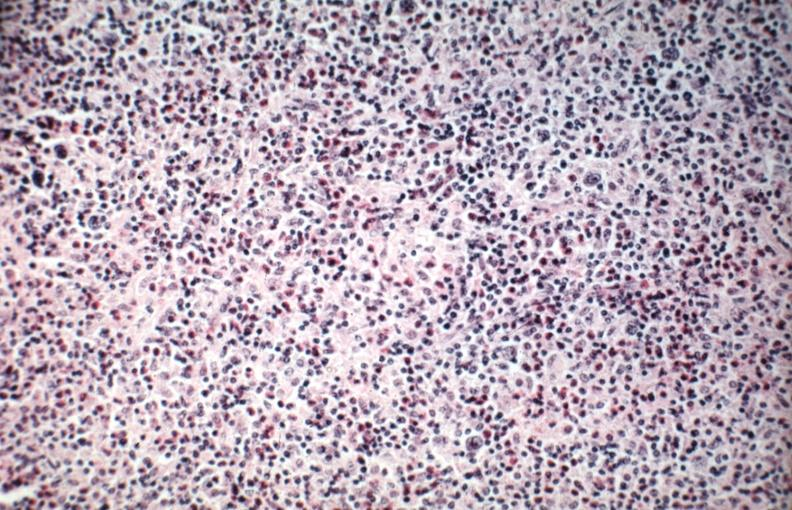what is present?
Answer the question using a single word or phrase. Hodgkins disease 